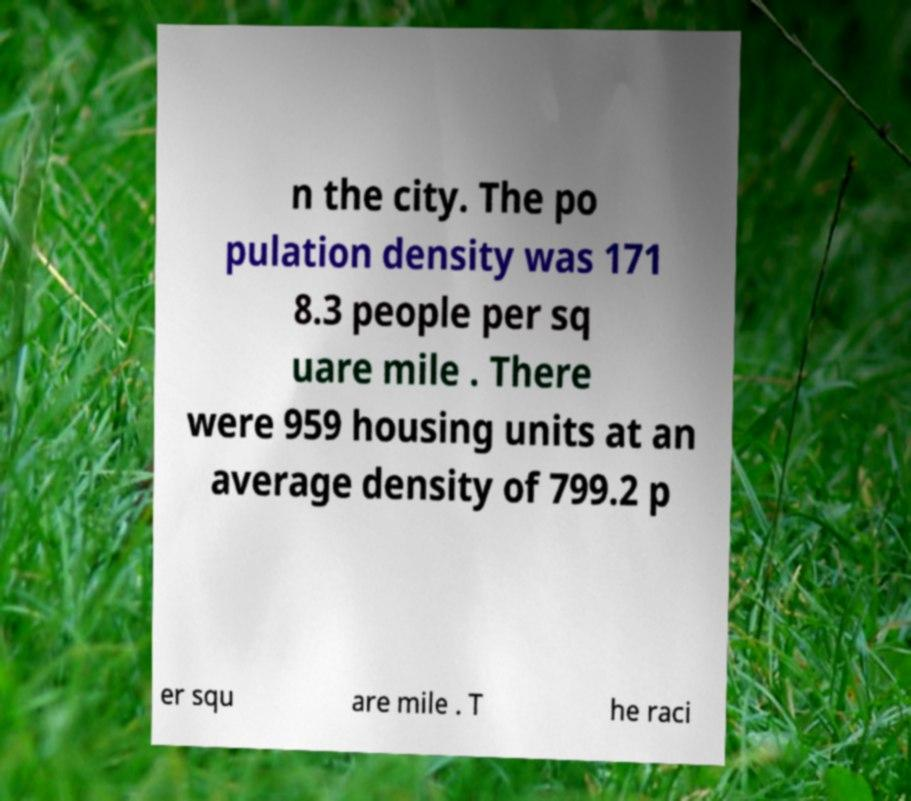Could you assist in decoding the text presented in this image and type it out clearly? n the city. The po pulation density was 171 8.3 people per sq uare mile . There were 959 housing units at an average density of 799.2 p er squ are mile . T he raci 